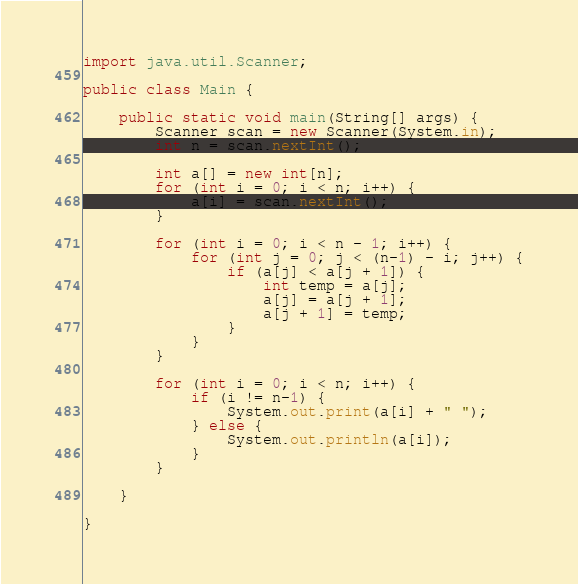<code> <loc_0><loc_0><loc_500><loc_500><_Java_>import java.util.Scanner;

public class Main {

	public static void main(String[] args) {
		Scanner scan = new Scanner(System.in);
		int n = scan.nextInt();

		int a[] = new int[n];
		for (int i = 0; i < n; i++) {
			a[i] = scan.nextInt();
		}

		for (int i = 0; i < n - 1; i++) {
			for (int j = 0; j < (n-1) - i; j++) {
				if (a[j] < a[j + 1]) {
					int temp = a[j];
					a[j] = a[j + 1];
					a[j + 1] = temp;
				}
			}
		}

		for (int i = 0; i < n; i++) {
			if (i != n-1) {
				System.out.print(a[i] + " ");
			} else {
				System.out.println(a[i]);
			}
		}

	}

}</code> 